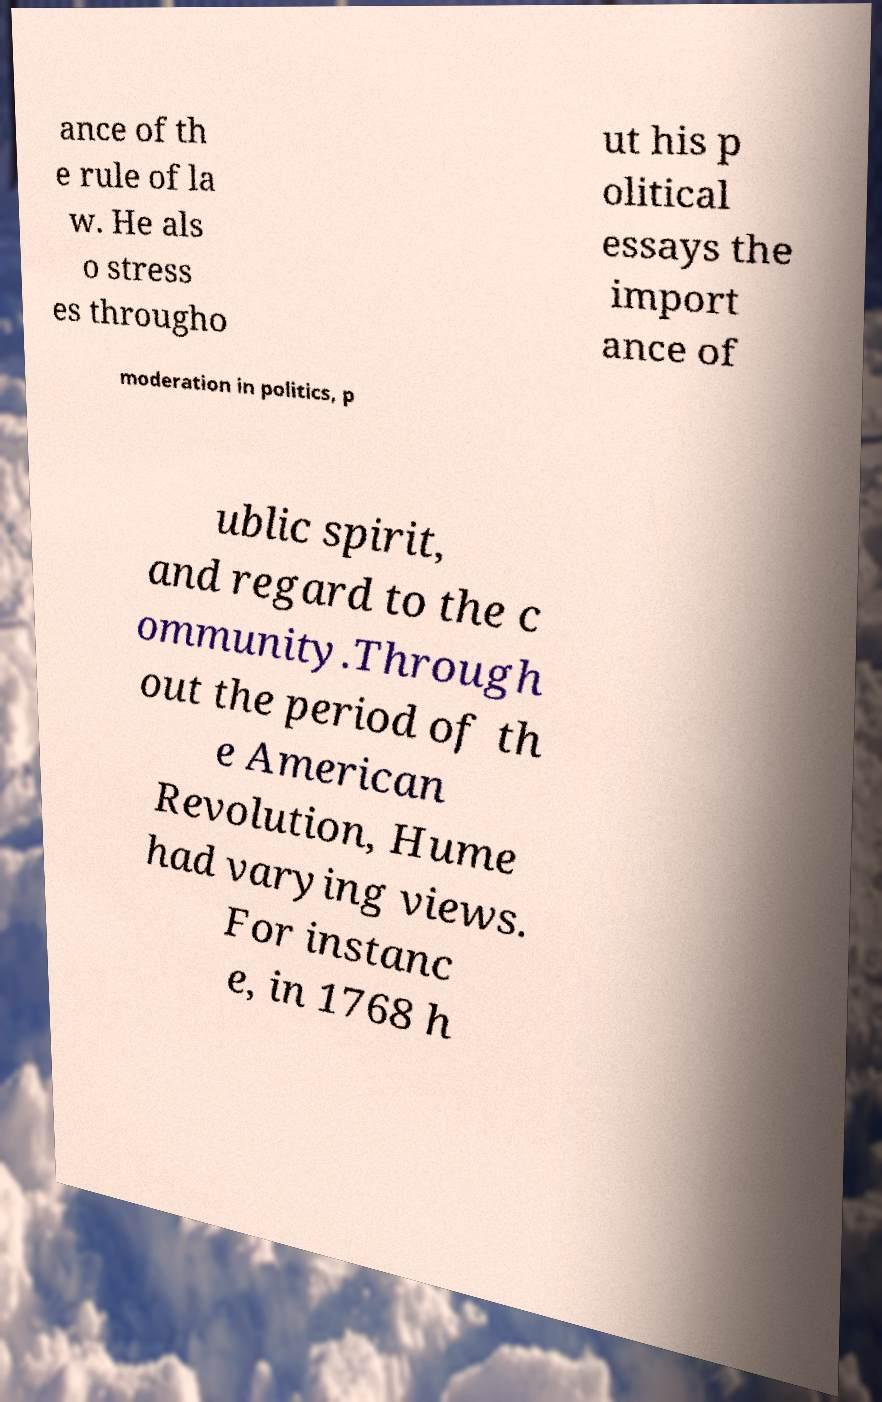Please read and relay the text visible in this image. What does it say? ance of th e rule of la w. He als o stress es througho ut his p olitical essays the import ance of moderation in politics, p ublic spirit, and regard to the c ommunity.Through out the period of th e American Revolution, Hume had varying views. For instanc e, in 1768 h 